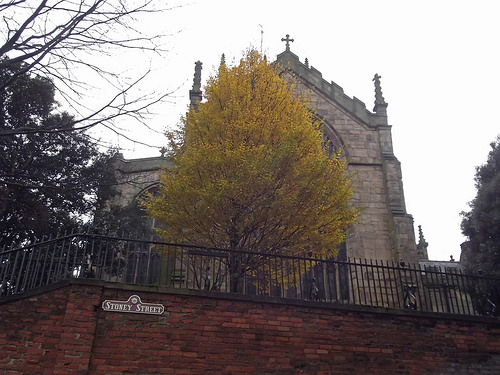<image>
Is the tree in the sky? No. The tree is not contained within the sky. These objects have a different spatial relationship. 